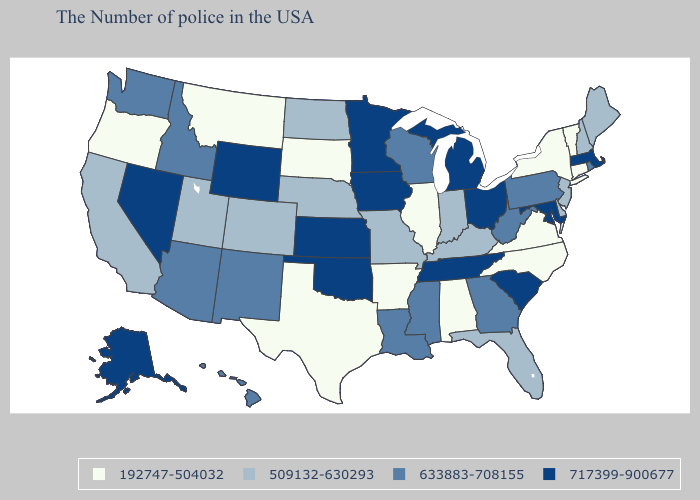Does the map have missing data?
Write a very short answer. No. Does Oregon have the highest value in the USA?
Give a very brief answer. No. Does Maine have a lower value than Wyoming?
Quick response, please. Yes. Which states have the lowest value in the USA?
Give a very brief answer. Vermont, Connecticut, New York, Virginia, North Carolina, Alabama, Illinois, Arkansas, Texas, South Dakota, Montana, Oregon. Does Alabama have the lowest value in the USA?
Quick response, please. Yes. Does New York have a higher value than Idaho?
Give a very brief answer. No. Does Utah have a lower value than Ohio?
Be succinct. Yes. Does New Jersey have the lowest value in the USA?
Be succinct. No. What is the value of Connecticut?
Keep it brief. 192747-504032. Among the states that border Montana , which have the lowest value?
Write a very short answer. South Dakota. Is the legend a continuous bar?
Give a very brief answer. No. Does South Carolina have a higher value than North Carolina?
Write a very short answer. Yes. What is the value of Florida?
Give a very brief answer. 509132-630293. Does South Dakota have the same value as Colorado?
Be succinct. No. What is the value of Illinois?
Concise answer only. 192747-504032. 